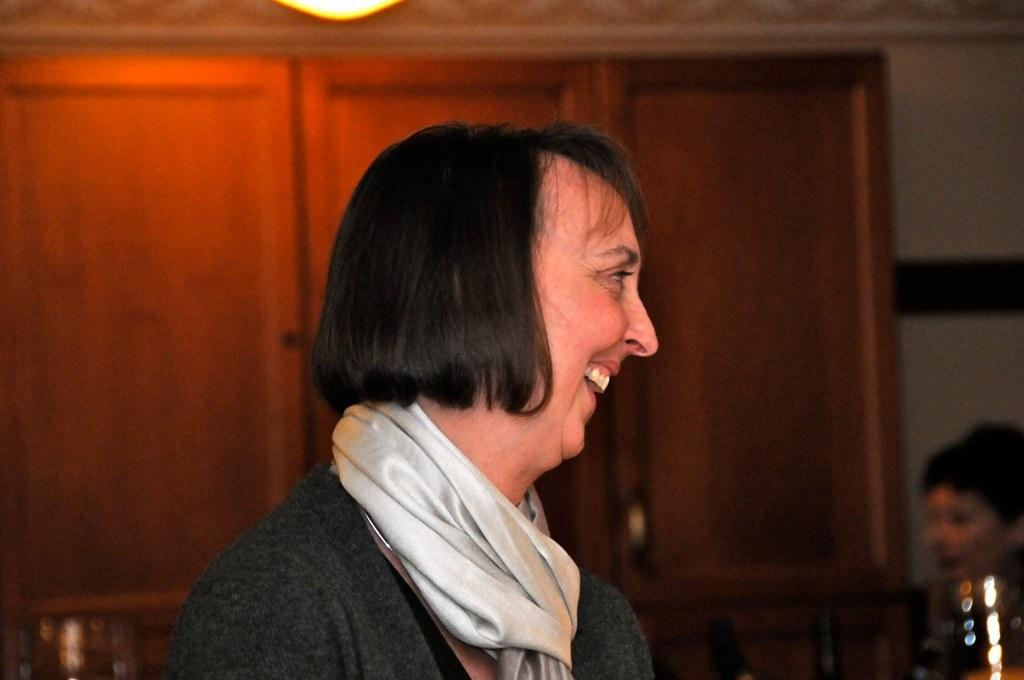What is the main subject in the foreground of the image? There is a person in the foreground of the image. What is the person doing in the image? The person is smiling. What can be seen in the background of the image? There are cupboards, at least one person object, a wall, and a light in the background of the image. What decision is the person making in the image? There is no indication in the image that the person is making a decision. 